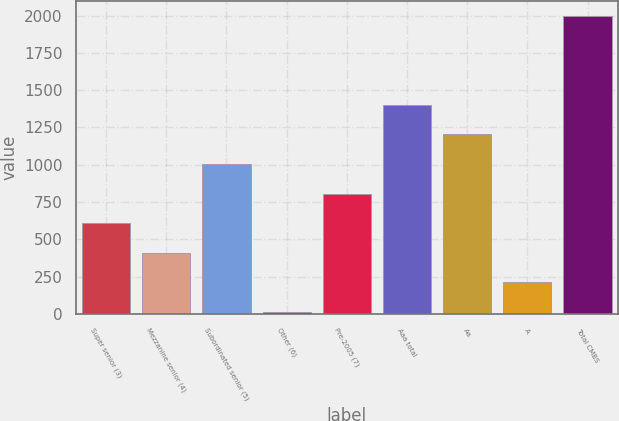Convert chart to OTSL. <chart><loc_0><loc_0><loc_500><loc_500><bar_chart><fcel>Super senior (3)<fcel>Mezzanine senior (4)<fcel>Subordinated senior (5)<fcel>Other (6)<fcel>Pre-2005 (7)<fcel>Aaa total<fcel>Aa<fcel>A<fcel>Total CMBS<nl><fcel>607.9<fcel>409.6<fcel>1004.5<fcel>13<fcel>806.2<fcel>1401.1<fcel>1202.8<fcel>211.3<fcel>1996<nl></chart> 